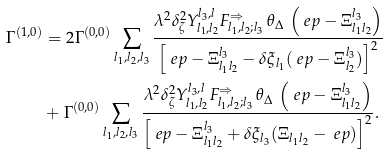Convert formula to latex. <formula><loc_0><loc_0><loc_500><loc_500>\Gamma ^ { ( 1 , 0 ) } & = 2 \Gamma ^ { ( 0 , 0 ) } \sum _ { l _ { 1 } , l _ { 2 } , l _ { 3 } } \frac { \lambda ^ { 2 } \delta _ { \zeta } ^ { 2 } Y _ { l _ { 1 } , l _ { 2 } } ^ { l _ { 3 } , l } F _ { l _ { 1 } , l _ { 2 } ; l _ { 3 } } ^ { \Rightarrow } \, \theta _ { \Delta } \, \left ( \ e p - \Xi _ { l _ { 1 } l _ { 2 } } ^ { l _ { 3 } } \right ) } { \left [ \ e p - \Xi _ { l _ { 1 } l _ { 2 } } ^ { l _ { 3 } } - \delta \xi _ { l _ { 1 } } ( \ e p - \Xi _ { l _ { 2 } } ^ { l _ { 3 } } ) \right ] ^ { 2 } } \\ & + \Gamma ^ { ( 0 , 0 ) } \sum _ { l _ { 1 } , l _ { 2 } , l _ { 3 } } \frac { \lambda ^ { 2 } \delta _ { \zeta } ^ { 2 } Y _ { l _ { 1 } , l _ { 2 } } ^ { l _ { 3 } , l } F _ { l _ { 1 } , l _ { 2 } ; l _ { 3 } } ^ { \Rightarrow } \, \theta _ { \Delta } \, \left ( \ e p - \Xi _ { l _ { 1 } l _ { 2 } } ^ { l _ { 3 } } \right ) } { \left [ \ e p - \Xi _ { l _ { 1 } l _ { 2 } } ^ { l _ { 3 } } + \delta \xi _ { l _ { 3 } } ( \Xi _ { l _ { 1 } l _ { 2 } } - \ e p ) \right ] ^ { 2 } } .</formula> 